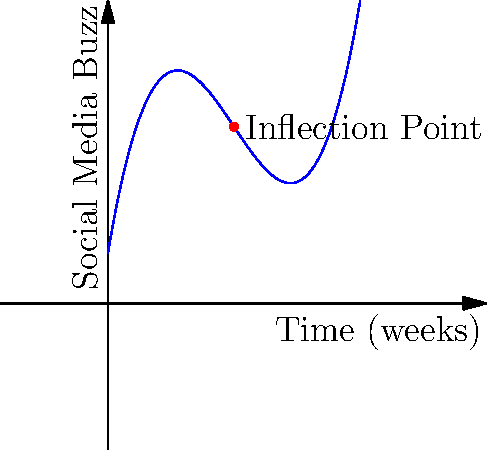The graph shows the social media buzz leading up to your indie film premiere over 10 weeks. The function modeling this buzz is given by $f(x) = 0.1x^3 - 1.5x^2 + 6x + 2$, where $x$ represents the number of weeks before the premiere. Find the inflection point of this curve, which represents the moment when the rate of change in social media buzz shifts from increasing to decreasing. To find the inflection point, we need to follow these steps:

1) The inflection point occurs where the second derivative of the function equals zero.

2) First, let's find the first derivative:
   $f'(x) = 0.3x^2 - 3x + 6$

3) Now, let's find the second derivative:
   $f''(x) = 0.6x - 3$

4) Set the second derivative equal to zero and solve for x:
   $0.6x - 3 = 0$
   $0.6x = 3$
   $x = 5$

5) To confirm this is an inflection point, we can check that $f''(x)$ changes sign at $x=5$:
   $f''(4) = 0.6(4) - 3 = -0.6$ (negative)
   $f''(6) = 0.6(6) - 3 = 0.6$ (positive)

6) Calculate the y-coordinate by plugging x=5 into the original function:
   $f(5) = 0.1(5^3) - 1.5(5^2) + 6(5) + 2 = 12.5$

Therefore, the inflection point is at (5, 12.5), occurring 5 weeks before the premiere.
Answer: (5, 12.5) 